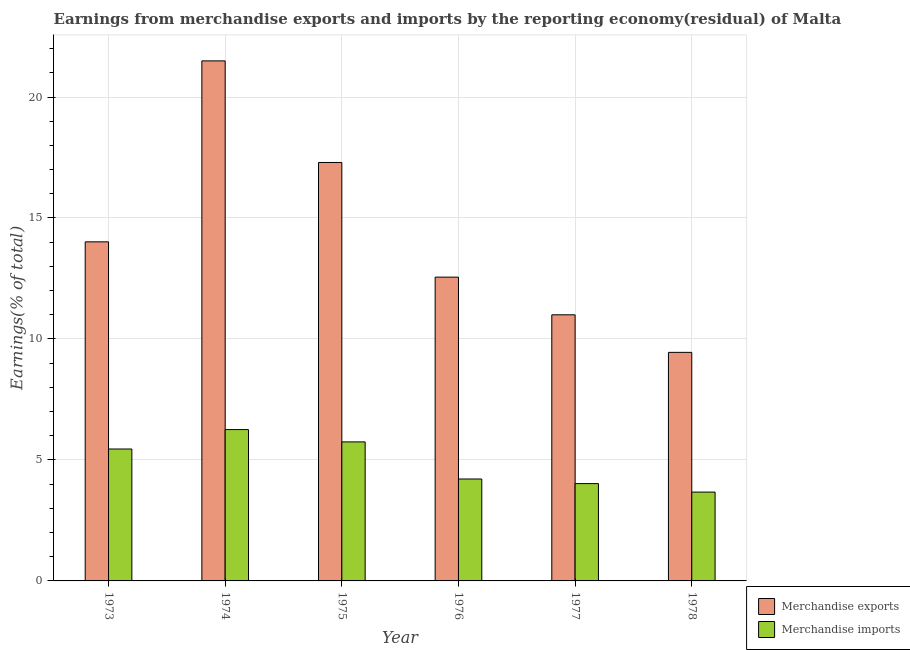How many different coloured bars are there?
Your answer should be very brief. 2. How many groups of bars are there?
Provide a succinct answer. 6. Are the number of bars per tick equal to the number of legend labels?
Provide a succinct answer. Yes. How many bars are there on the 2nd tick from the left?
Give a very brief answer. 2. In how many cases, is the number of bars for a given year not equal to the number of legend labels?
Ensure brevity in your answer.  0. What is the earnings from merchandise exports in 1977?
Ensure brevity in your answer.  11. Across all years, what is the maximum earnings from merchandise imports?
Provide a short and direct response. 6.25. Across all years, what is the minimum earnings from merchandise imports?
Make the answer very short. 3.67. In which year was the earnings from merchandise exports maximum?
Offer a very short reply. 1974. In which year was the earnings from merchandise exports minimum?
Your answer should be very brief. 1978. What is the total earnings from merchandise exports in the graph?
Your answer should be very brief. 85.8. What is the difference between the earnings from merchandise exports in 1976 and that in 1977?
Keep it short and to the point. 1.56. What is the difference between the earnings from merchandise imports in 1977 and the earnings from merchandise exports in 1974?
Offer a terse response. -2.23. What is the average earnings from merchandise exports per year?
Your answer should be very brief. 14.3. In the year 1978, what is the difference between the earnings from merchandise exports and earnings from merchandise imports?
Offer a terse response. 0. What is the ratio of the earnings from merchandise exports in 1975 to that in 1977?
Provide a succinct answer. 1.57. Is the earnings from merchandise exports in 1974 less than that in 1978?
Offer a very short reply. No. Is the difference between the earnings from merchandise exports in 1976 and 1977 greater than the difference between the earnings from merchandise imports in 1976 and 1977?
Keep it short and to the point. No. What is the difference between the highest and the second highest earnings from merchandise exports?
Make the answer very short. 4.2. What is the difference between the highest and the lowest earnings from merchandise exports?
Your answer should be very brief. 12.05. Is the sum of the earnings from merchandise exports in 1974 and 1975 greater than the maximum earnings from merchandise imports across all years?
Ensure brevity in your answer.  Yes. What is the difference between two consecutive major ticks on the Y-axis?
Your answer should be compact. 5. Are the values on the major ticks of Y-axis written in scientific E-notation?
Provide a short and direct response. No. Does the graph contain any zero values?
Your response must be concise. No. Does the graph contain grids?
Your answer should be very brief. Yes. How many legend labels are there?
Your response must be concise. 2. How are the legend labels stacked?
Your answer should be compact. Vertical. What is the title of the graph?
Provide a succinct answer. Earnings from merchandise exports and imports by the reporting economy(residual) of Malta. Does "Gasoline" appear as one of the legend labels in the graph?
Keep it short and to the point. No. What is the label or title of the Y-axis?
Make the answer very short. Earnings(% of total). What is the Earnings(% of total) of Merchandise exports in 1973?
Offer a very short reply. 14.01. What is the Earnings(% of total) in Merchandise imports in 1973?
Provide a short and direct response. 5.45. What is the Earnings(% of total) in Merchandise exports in 1974?
Your answer should be compact. 21.49. What is the Earnings(% of total) of Merchandise imports in 1974?
Provide a succinct answer. 6.25. What is the Earnings(% of total) in Merchandise exports in 1975?
Give a very brief answer. 17.29. What is the Earnings(% of total) in Merchandise imports in 1975?
Your answer should be very brief. 5.75. What is the Earnings(% of total) in Merchandise exports in 1976?
Offer a terse response. 12.56. What is the Earnings(% of total) in Merchandise imports in 1976?
Provide a succinct answer. 4.21. What is the Earnings(% of total) in Merchandise exports in 1977?
Make the answer very short. 11. What is the Earnings(% of total) in Merchandise imports in 1977?
Offer a terse response. 4.02. What is the Earnings(% of total) in Merchandise exports in 1978?
Provide a short and direct response. 9.45. What is the Earnings(% of total) of Merchandise imports in 1978?
Provide a short and direct response. 3.67. Across all years, what is the maximum Earnings(% of total) of Merchandise exports?
Offer a very short reply. 21.49. Across all years, what is the maximum Earnings(% of total) in Merchandise imports?
Keep it short and to the point. 6.25. Across all years, what is the minimum Earnings(% of total) of Merchandise exports?
Offer a very short reply. 9.45. Across all years, what is the minimum Earnings(% of total) of Merchandise imports?
Provide a succinct answer. 3.67. What is the total Earnings(% of total) in Merchandise exports in the graph?
Keep it short and to the point. 85.8. What is the total Earnings(% of total) of Merchandise imports in the graph?
Ensure brevity in your answer.  29.36. What is the difference between the Earnings(% of total) in Merchandise exports in 1973 and that in 1974?
Your response must be concise. -7.48. What is the difference between the Earnings(% of total) in Merchandise imports in 1973 and that in 1974?
Provide a succinct answer. -0.8. What is the difference between the Earnings(% of total) in Merchandise exports in 1973 and that in 1975?
Offer a very short reply. -3.28. What is the difference between the Earnings(% of total) of Merchandise imports in 1973 and that in 1975?
Give a very brief answer. -0.29. What is the difference between the Earnings(% of total) in Merchandise exports in 1973 and that in 1976?
Your answer should be very brief. 1.46. What is the difference between the Earnings(% of total) of Merchandise imports in 1973 and that in 1976?
Offer a terse response. 1.24. What is the difference between the Earnings(% of total) of Merchandise exports in 1973 and that in 1977?
Your answer should be compact. 3.02. What is the difference between the Earnings(% of total) in Merchandise imports in 1973 and that in 1977?
Give a very brief answer. 1.43. What is the difference between the Earnings(% of total) in Merchandise exports in 1973 and that in 1978?
Make the answer very short. 4.57. What is the difference between the Earnings(% of total) in Merchandise imports in 1973 and that in 1978?
Make the answer very short. 1.78. What is the difference between the Earnings(% of total) in Merchandise exports in 1974 and that in 1975?
Give a very brief answer. 4.2. What is the difference between the Earnings(% of total) in Merchandise imports in 1974 and that in 1975?
Ensure brevity in your answer.  0.51. What is the difference between the Earnings(% of total) of Merchandise exports in 1974 and that in 1976?
Give a very brief answer. 8.94. What is the difference between the Earnings(% of total) of Merchandise imports in 1974 and that in 1976?
Make the answer very short. 2.04. What is the difference between the Earnings(% of total) in Merchandise exports in 1974 and that in 1977?
Your answer should be very brief. 10.49. What is the difference between the Earnings(% of total) in Merchandise imports in 1974 and that in 1977?
Make the answer very short. 2.23. What is the difference between the Earnings(% of total) of Merchandise exports in 1974 and that in 1978?
Your answer should be very brief. 12.05. What is the difference between the Earnings(% of total) of Merchandise imports in 1974 and that in 1978?
Ensure brevity in your answer.  2.58. What is the difference between the Earnings(% of total) of Merchandise exports in 1975 and that in 1976?
Provide a short and direct response. 4.74. What is the difference between the Earnings(% of total) of Merchandise imports in 1975 and that in 1976?
Offer a terse response. 1.53. What is the difference between the Earnings(% of total) in Merchandise exports in 1975 and that in 1977?
Your answer should be very brief. 6.3. What is the difference between the Earnings(% of total) of Merchandise imports in 1975 and that in 1977?
Provide a succinct answer. 1.72. What is the difference between the Earnings(% of total) in Merchandise exports in 1975 and that in 1978?
Make the answer very short. 7.85. What is the difference between the Earnings(% of total) of Merchandise imports in 1975 and that in 1978?
Provide a short and direct response. 2.07. What is the difference between the Earnings(% of total) in Merchandise exports in 1976 and that in 1977?
Your answer should be compact. 1.56. What is the difference between the Earnings(% of total) in Merchandise imports in 1976 and that in 1977?
Your answer should be very brief. 0.19. What is the difference between the Earnings(% of total) of Merchandise exports in 1976 and that in 1978?
Ensure brevity in your answer.  3.11. What is the difference between the Earnings(% of total) of Merchandise imports in 1976 and that in 1978?
Provide a succinct answer. 0.54. What is the difference between the Earnings(% of total) of Merchandise exports in 1977 and that in 1978?
Ensure brevity in your answer.  1.55. What is the difference between the Earnings(% of total) of Merchandise imports in 1977 and that in 1978?
Provide a short and direct response. 0.35. What is the difference between the Earnings(% of total) of Merchandise exports in 1973 and the Earnings(% of total) of Merchandise imports in 1974?
Offer a very short reply. 7.76. What is the difference between the Earnings(% of total) of Merchandise exports in 1973 and the Earnings(% of total) of Merchandise imports in 1975?
Provide a succinct answer. 8.27. What is the difference between the Earnings(% of total) of Merchandise exports in 1973 and the Earnings(% of total) of Merchandise imports in 1976?
Offer a very short reply. 9.8. What is the difference between the Earnings(% of total) in Merchandise exports in 1973 and the Earnings(% of total) in Merchandise imports in 1977?
Offer a terse response. 9.99. What is the difference between the Earnings(% of total) of Merchandise exports in 1973 and the Earnings(% of total) of Merchandise imports in 1978?
Provide a short and direct response. 10.34. What is the difference between the Earnings(% of total) of Merchandise exports in 1974 and the Earnings(% of total) of Merchandise imports in 1975?
Provide a short and direct response. 15.75. What is the difference between the Earnings(% of total) of Merchandise exports in 1974 and the Earnings(% of total) of Merchandise imports in 1976?
Give a very brief answer. 17.28. What is the difference between the Earnings(% of total) in Merchandise exports in 1974 and the Earnings(% of total) in Merchandise imports in 1977?
Your answer should be very brief. 17.47. What is the difference between the Earnings(% of total) of Merchandise exports in 1974 and the Earnings(% of total) of Merchandise imports in 1978?
Your response must be concise. 17.82. What is the difference between the Earnings(% of total) of Merchandise exports in 1975 and the Earnings(% of total) of Merchandise imports in 1976?
Offer a very short reply. 13.08. What is the difference between the Earnings(% of total) of Merchandise exports in 1975 and the Earnings(% of total) of Merchandise imports in 1977?
Your answer should be very brief. 13.27. What is the difference between the Earnings(% of total) in Merchandise exports in 1975 and the Earnings(% of total) in Merchandise imports in 1978?
Make the answer very short. 13.62. What is the difference between the Earnings(% of total) in Merchandise exports in 1976 and the Earnings(% of total) in Merchandise imports in 1977?
Ensure brevity in your answer.  8.53. What is the difference between the Earnings(% of total) in Merchandise exports in 1976 and the Earnings(% of total) in Merchandise imports in 1978?
Give a very brief answer. 8.88. What is the difference between the Earnings(% of total) of Merchandise exports in 1977 and the Earnings(% of total) of Merchandise imports in 1978?
Give a very brief answer. 7.33. What is the average Earnings(% of total) of Merchandise exports per year?
Provide a short and direct response. 14.3. What is the average Earnings(% of total) of Merchandise imports per year?
Your answer should be compact. 4.89. In the year 1973, what is the difference between the Earnings(% of total) of Merchandise exports and Earnings(% of total) of Merchandise imports?
Give a very brief answer. 8.56. In the year 1974, what is the difference between the Earnings(% of total) in Merchandise exports and Earnings(% of total) in Merchandise imports?
Your answer should be very brief. 15.24. In the year 1975, what is the difference between the Earnings(% of total) in Merchandise exports and Earnings(% of total) in Merchandise imports?
Your answer should be very brief. 11.55. In the year 1976, what is the difference between the Earnings(% of total) of Merchandise exports and Earnings(% of total) of Merchandise imports?
Give a very brief answer. 8.34. In the year 1977, what is the difference between the Earnings(% of total) of Merchandise exports and Earnings(% of total) of Merchandise imports?
Your answer should be very brief. 6.98. In the year 1978, what is the difference between the Earnings(% of total) in Merchandise exports and Earnings(% of total) in Merchandise imports?
Provide a short and direct response. 5.77. What is the ratio of the Earnings(% of total) of Merchandise exports in 1973 to that in 1974?
Your answer should be very brief. 0.65. What is the ratio of the Earnings(% of total) in Merchandise imports in 1973 to that in 1974?
Your answer should be compact. 0.87. What is the ratio of the Earnings(% of total) in Merchandise exports in 1973 to that in 1975?
Offer a terse response. 0.81. What is the ratio of the Earnings(% of total) of Merchandise imports in 1973 to that in 1975?
Provide a short and direct response. 0.95. What is the ratio of the Earnings(% of total) of Merchandise exports in 1973 to that in 1976?
Keep it short and to the point. 1.12. What is the ratio of the Earnings(% of total) of Merchandise imports in 1973 to that in 1976?
Provide a short and direct response. 1.29. What is the ratio of the Earnings(% of total) of Merchandise exports in 1973 to that in 1977?
Your answer should be very brief. 1.27. What is the ratio of the Earnings(% of total) of Merchandise imports in 1973 to that in 1977?
Your response must be concise. 1.36. What is the ratio of the Earnings(% of total) of Merchandise exports in 1973 to that in 1978?
Keep it short and to the point. 1.48. What is the ratio of the Earnings(% of total) in Merchandise imports in 1973 to that in 1978?
Make the answer very short. 1.48. What is the ratio of the Earnings(% of total) of Merchandise exports in 1974 to that in 1975?
Your answer should be very brief. 1.24. What is the ratio of the Earnings(% of total) in Merchandise imports in 1974 to that in 1975?
Provide a short and direct response. 1.09. What is the ratio of the Earnings(% of total) in Merchandise exports in 1974 to that in 1976?
Provide a succinct answer. 1.71. What is the ratio of the Earnings(% of total) of Merchandise imports in 1974 to that in 1976?
Your answer should be very brief. 1.48. What is the ratio of the Earnings(% of total) in Merchandise exports in 1974 to that in 1977?
Keep it short and to the point. 1.95. What is the ratio of the Earnings(% of total) in Merchandise imports in 1974 to that in 1977?
Your answer should be compact. 1.56. What is the ratio of the Earnings(% of total) in Merchandise exports in 1974 to that in 1978?
Offer a very short reply. 2.28. What is the ratio of the Earnings(% of total) in Merchandise imports in 1974 to that in 1978?
Make the answer very short. 1.7. What is the ratio of the Earnings(% of total) of Merchandise exports in 1975 to that in 1976?
Your answer should be compact. 1.38. What is the ratio of the Earnings(% of total) in Merchandise imports in 1975 to that in 1976?
Provide a succinct answer. 1.36. What is the ratio of the Earnings(% of total) of Merchandise exports in 1975 to that in 1977?
Offer a very short reply. 1.57. What is the ratio of the Earnings(% of total) of Merchandise imports in 1975 to that in 1977?
Provide a short and direct response. 1.43. What is the ratio of the Earnings(% of total) of Merchandise exports in 1975 to that in 1978?
Ensure brevity in your answer.  1.83. What is the ratio of the Earnings(% of total) of Merchandise imports in 1975 to that in 1978?
Make the answer very short. 1.56. What is the ratio of the Earnings(% of total) of Merchandise exports in 1976 to that in 1977?
Keep it short and to the point. 1.14. What is the ratio of the Earnings(% of total) in Merchandise imports in 1976 to that in 1977?
Your answer should be very brief. 1.05. What is the ratio of the Earnings(% of total) of Merchandise exports in 1976 to that in 1978?
Your answer should be very brief. 1.33. What is the ratio of the Earnings(% of total) in Merchandise imports in 1976 to that in 1978?
Provide a short and direct response. 1.15. What is the ratio of the Earnings(% of total) of Merchandise exports in 1977 to that in 1978?
Provide a short and direct response. 1.16. What is the ratio of the Earnings(% of total) in Merchandise imports in 1977 to that in 1978?
Your answer should be very brief. 1.1. What is the difference between the highest and the second highest Earnings(% of total) in Merchandise exports?
Make the answer very short. 4.2. What is the difference between the highest and the second highest Earnings(% of total) of Merchandise imports?
Offer a very short reply. 0.51. What is the difference between the highest and the lowest Earnings(% of total) in Merchandise exports?
Your answer should be very brief. 12.05. What is the difference between the highest and the lowest Earnings(% of total) in Merchandise imports?
Your answer should be compact. 2.58. 